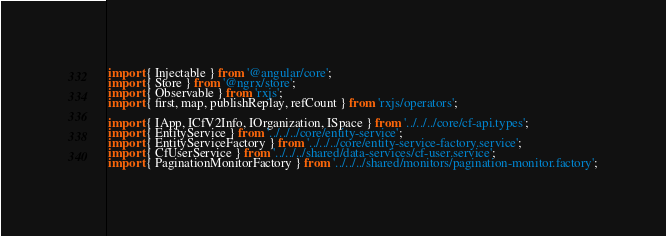Convert code to text. <code><loc_0><loc_0><loc_500><loc_500><_TypeScript_>import { Injectable } from '@angular/core';
import { Store } from '@ngrx/store';
import { Observable } from 'rxjs';
import { first, map, publishReplay, refCount } from 'rxjs/operators';

import { IApp, ICfV2Info, IOrganization, ISpace } from '../../../core/cf-api.types';
import { EntityService } from '../../../core/entity-service';
import { EntityServiceFactory } from '../../../core/entity-service-factory.service';
import { CfUserService } from '../../../shared/data-services/cf-user.service';
import { PaginationMonitorFactory } from '../../../shared/monitors/pagination-monitor.factory';</code> 